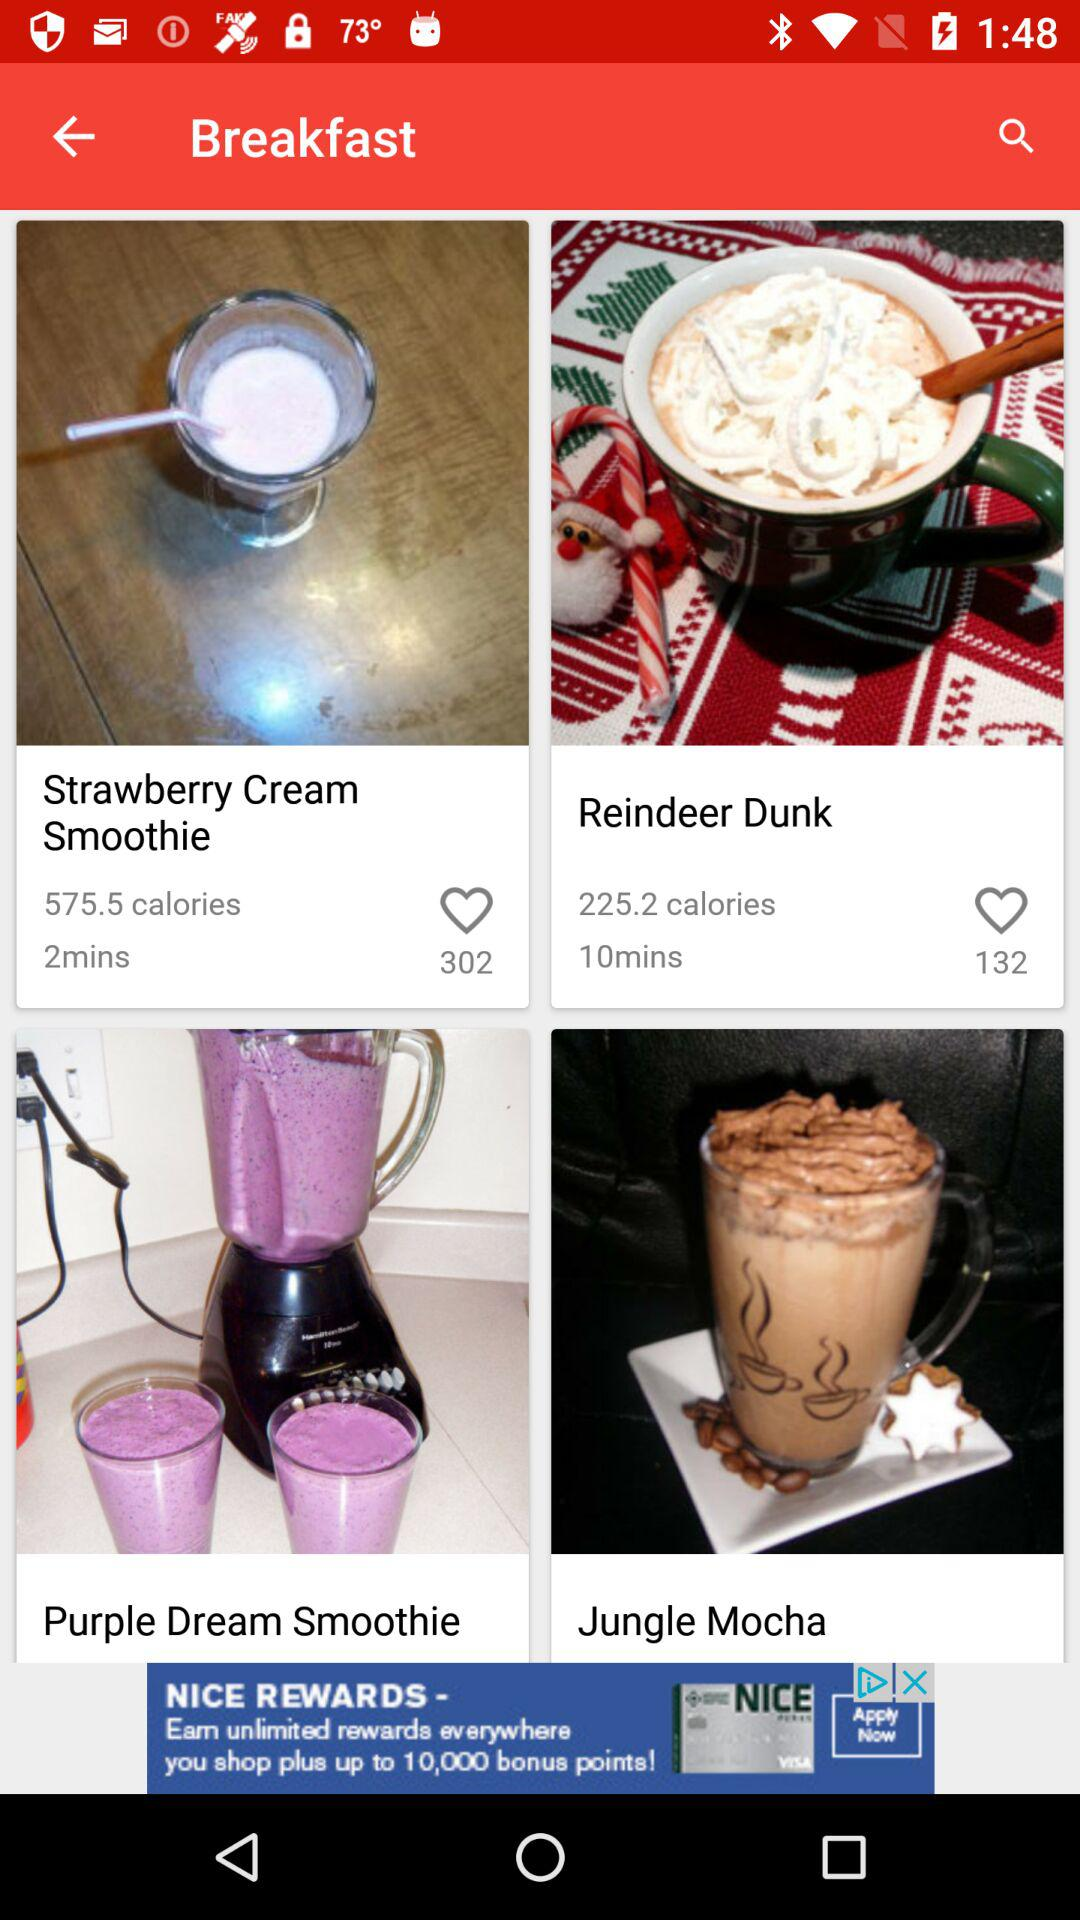How many reviews are there for Reindeer Dunk? There are 132 reviews for Reindeer Dunk. 